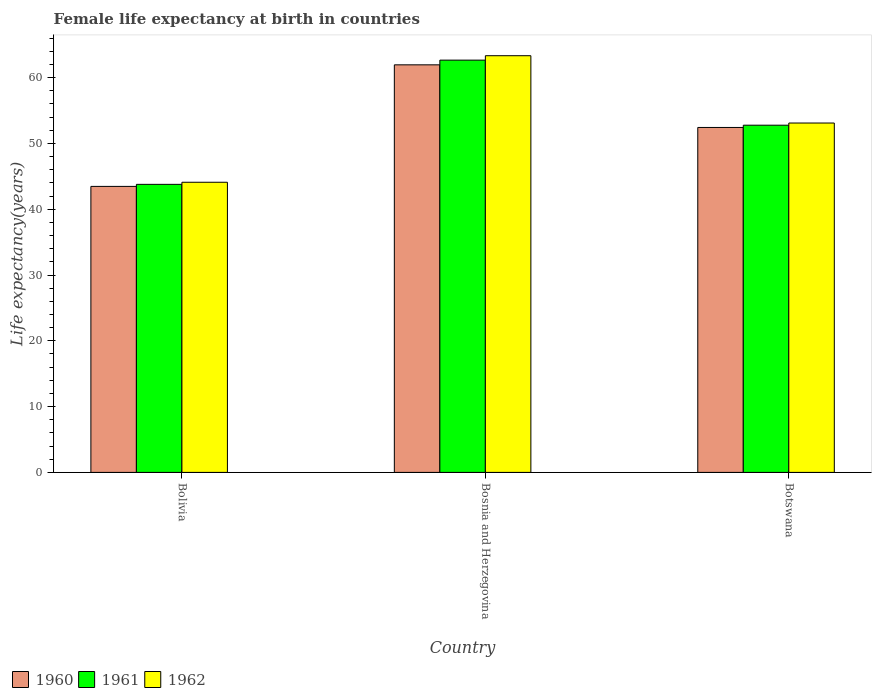How many groups of bars are there?
Ensure brevity in your answer.  3. Are the number of bars per tick equal to the number of legend labels?
Offer a very short reply. Yes. How many bars are there on the 2nd tick from the right?
Provide a short and direct response. 3. What is the label of the 2nd group of bars from the left?
Provide a short and direct response. Bosnia and Herzegovina. What is the female life expectancy at birth in 1960 in Bolivia?
Offer a terse response. 43.47. Across all countries, what is the maximum female life expectancy at birth in 1960?
Your answer should be compact. 61.95. Across all countries, what is the minimum female life expectancy at birth in 1962?
Provide a succinct answer. 44.1. In which country was the female life expectancy at birth in 1961 maximum?
Provide a succinct answer. Bosnia and Herzegovina. What is the total female life expectancy at birth in 1962 in the graph?
Your answer should be compact. 160.53. What is the difference between the female life expectancy at birth in 1961 in Bolivia and that in Botswana?
Provide a succinct answer. -8.99. What is the difference between the female life expectancy at birth in 1961 in Bosnia and Herzegovina and the female life expectancy at birth in 1962 in Bolivia?
Your answer should be compact. 18.56. What is the average female life expectancy at birth in 1962 per country?
Offer a terse response. 53.51. What is the difference between the female life expectancy at birth of/in 1960 and female life expectancy at birth of/in 1961 in Botswana?
Make the answer very short. -0.34. What is the ratio of the female life expectancy at birth in 1962 in Bolivia to that in Bosnia and Herzegovina?
Keep it short and to the point. 0.7. Is the female life expectancy at birth in 1961 in Bosnia and Herzegovina less than that in Botswana?
Your answer should be very brief. No. What is the difference between the highest and the second highest female life expectancy at birth in 1962?
Provide a succinct answer. -9. What is the difference between the highest and the lowest female life expectancy at birth in 1961?
Ensure brevity in your answer.  18.88. In how many countries, is the female life expectancy at birth in 1961 greater than the average female life expectancy at birth in 1961 taken over all countries?
Your answer should be very brief. 1. Is the sum of the female life expectancy at birth in 1960 in Bolivia and Botswana greater than the maximum female life expectancy at birth in 1962 across all countries?
Provide a short and direct response. Yes. What does the 3rd bar from the left in Bosnia and Herzegovina represents?
Ensure brevity in your answer.  1962. What does the 2nd bar from the right in Botswana represents?
Make the answer very short. 1961. Are the values on the major ticks of Y-axis written in scientific E-notation?
Offer a very short reply. No. What is the title of the graph?
Provide a short and direct response. Female life expectancy at birth in countries. Does "1981" appear as one of the legend labels in the graph?
Your answer should be very brief. No. What is the label or title of the Y-axis?
Offer a very short reply. Life expectancy(years). What is the Life expectancy(years) of 1960 in Bolivia?
Make the answer very short. 43.47. What is the Life expectancy(years) in 1961 in Bolivia?
Keep it short and to the point. 43.78. What is the Life expectancy(years) of 1962 in Bolivia?
Make the answer very short. 44.1. What is the Life expectancy(years) of 1960 in Bosnia and Herzegovina?
Provide a short and direct response. 61.95. What is the Life expectancy(years) of 1961 in Bosnia and Herzegovina?
Provide a short and direct response. 62.66. What is the Life expectancy(years) in 1962 in Bosnia and Herzegovina?
Keep it short and to the point. 63.33. What is the Life expectancy(years) in 1960 in Botswana?
Offer a very short reply. 52.43. What is the Life expectancy(years) of 1961 in Botswana?
Offer a very short reply. 52.77. What is the Life expectancy(years) in 1962 in Botswana?
Offer a terse response. 53.1. Across all countries, what is the maximum Life expectancy(years) of 1960?
Give a very brief answer. 61.95. Across all countries, what is the maximum Life expectancy(years) of 1961?
Provide a succinct answer. 62.66. Across all countries, what is the maximum Life expectancy(years) in 1962?
Your answer should be very brief. 63.33. Across all countries, what is the minimum Life expectancy(years) of 1960?
Your answer should be compact. 43.47. Across all countries, what is the minimum Life expectancy(years) in 1961?
Your answer should be compact. 43.78. Across all countries, what is the minimum Life expectancy(years) of 1962?
Your answer should be compact. 44.1. What is the total Life expectancy(years) of 1960 in the graph?
Offer a terse response. 157.84. What is the total Life expectancy(years) in 1961 in the graph?
Your answer should be compact. 159.21. What is the total Life expectancy(years) in 1962 in the graph?
Ensure brevity in your answer.  160.53. What is the difference between the Life expectancy(years) in 1960 in Bolivia and that in Bosnia and Herzegovina?
Keep it short and to the point. -18.48. What is the difference between the Life expectancy(years) in 1961 in Bolivia and that in Bosnia and Herzegovina?
Your answer should be very brief. -18.88. What is the difference between the Life expectancy(years) of 1962 in Bolivia and that in Bosnia and Herzegovina?
Your answer should be very brief. -19.23. What is the difference between the Life expectancy(years) in 1960 in Bolivia and that in Botswana?
Give a very brief answer. -8.96. What is the difference between the Life expectancy(years) in 1961 in Bolivia and that in Botswana?
Make the answer very short. -8.99. What is the difference between the Life expectancy(years) of 1962 in Bolivia and that in Botswana?
Offer a very short reply. -9. What is the difference between the Life expectancy(years) of 1960 in Bosnia and Herzegovina and that in Botswana?
Your response must be concise. 9.52. What is the difference between the Life expectancy(years) in 1961 in Bosnia and Herzegovina and that in Botswana?
Provide a short and direct response. 9.89. What is the difference between the Life expectancy(years) of 1962 in Bosnia and Herzegovina and that in Botswana?
Make the answer very short. 10.23. What is the difference between the Life expectancy(years) in 1960 in Bolivia and the Life expectancy(years) in 1961 in Bosnia and Herzegovina?
Provide a succinct answer. -19.19. What is the difference between the Life expectancy(years) in 1960 in Bolivia and the Life expectancy(years) in 1962 in Bosnia and Herzegovina?
Provide a succinct answer. -19.86. What is the difference between the Life expectancy(years) of 1961 in Bolivia and the Life expectancy(years) of 1962 in Bosnia and Herzegovina?
Your answer should be compact. -19.55. What is the difference between the Life expectancy(years) in 1960 in Bolivia and the Life expectancy(years) in 1961 in Botswana?
Ensure brevity in your answer.  -9.3. What is the difference between the Life expectancy(years) in 1960 in Bolivia and the Life expectancy(years) in 1962 in Botswana?
Ensure brevity in your answer.  -9.63. What is the difference between the Life expectancy(years) in 1961 in Bolivia and the Life expectancy(years) in 1962 in Botswana?
Offer a very short reply. -9.32. What is the difference between the Life expectancy(years) of 1960 in Bosnia and Herzegovina and the Life expectancy(years) of 1961 in Botswana?
Give a very brief answer. 9.18. What is the difference between the Life expectancy(years) of 1960 in Bosnia and Herzegovina and the Life expectancy(years) of 1962 in Botswana?
Provide a succinct answer. 8.85. What is the difference between the Life expectancy(years) of 1961 in Bosnia and Herzegovina and the Life expectancy(years) of 1962 in Botswana?
Offer a very short reply. 9.56. What is the average Life expectancy(years) of 1960 per country?
Keep it short and to the point. 52.62. What is the average Life expectancy(years) of 1961 per country?
Ensure brevity in your answer.  53.07. What is the average Life expectancy(years) of 1962 per country?
Provide a short and direct response. 53.51. What is the difference between the Life expectancy(years) of 1960 and Life expectancy(years) of 1961 in Bolivia?
Offer a terse response. -0.31. What is the difference between the Life expectancy(years) in 1960 and Life expectancy(years) in 1962 in Bolivia?
Offer a terse response. -0.63. What is the difference between the Life expectancy(years) in 1961 and Life expectancy(years) in 1962 in Bolivia?
Ensure brevity in your answer.  -0.32. What is the difference between the Life expectancy(years) of 1960 and Life expectancy(years) of 1961 in Bosnia and Herzegovina?
Keep it short and to the point. -0.71. What is the difference between the Life expectancy(years) in 1960 and Life expectancy(years) in 1962 in Bosnia and Herzegovina?
Provide a succinct answer. -1.39. What is the difference between the Life expectancy(years) of 1961 and Life expectancy(years) of 1962 in Bosnia and Herzegovina?
Keep it short and to the point. -0.67. What is the difference between the Life expectancy(years) of 1960 and Life expectancy(years) of 1961 in Botswana?
Your response must be concise. -0.34. What is the difference between the Life expectancy(years) of 1960 and Life expectancy(years) of 1962 in Botswana?
Offer a terse response. -0.67. What is the difference between the Life expectancy(years) of 1961 and Life expectancy(years) of 1962 in Botswana?
Give a very brief answer. -0.33. What is the ratio of the Life expectancy(years) of 1960 in Bolivia to that in Bosnia and Herzegovina?
Provide a short and direct response. 0.7. What is the ratio of the Life expectancy(years) of 1961 in Bolivia to that in Bosnia and Herzegovina?
Give a very brief answer. 0.7. What is the ratio of the Life expectancy(years) of 1962 in Bolivia to that in Bosnia and Herzegovina?
Provide a short and direct response. 0.7. What is the ratio of the Life expectancy(years) of 1960 in Bolivia to that in Botswana?
Your answer should be very brief. 0.83. What is the ratio of the Life expectancy(years) of 1961 in Bolivia to that in Botswana?
Make the answer very short. 0.83. What is the ratio of the Life expectancy(years) in 1962 in Bolivia to that in Botswana?
Ensure brevity in your answer.  0.83. What is the ratio of the Life expectancy(years) of 1960 in Bosnia and Herzegovina to that in Botswana?
Your answer should be very brief. 1.18. What is the ratio of the Life expectancy(years) in 1961 in Bosnia and Herzegovina to that in Botswana?
Offer a terse response. 1.19. What is the ratio of the Life expectancy(years) of 1962 in Bosnia and Herzegovina to that in Botswana?
Ensure brevity in your answer.  1.19. What is the difference between the highest and the second highest Life expectancy(years) in 1960?
Keep it short and to the point. 9.52. What is the difference between the highest and the second highest Life expectancy(years) in 1961?
Your answer should be compact. 9.89. What is the difference between the highest and the second highest Life expectancy(years) of 1962?
Provide a short and direct response. 10.23. What is the difference between the highest and the lowest Life expectancy(years) of 1960?
Your response must be concise. 18.48. What is the difference between the highest and the lowest Life expectancy(years) in 1961?
Offer a very short reply. 18.88. What is the difference between the highest and the lowest Life expectancy(years) of 1962?
Your answer should be very brief. 19.23. 